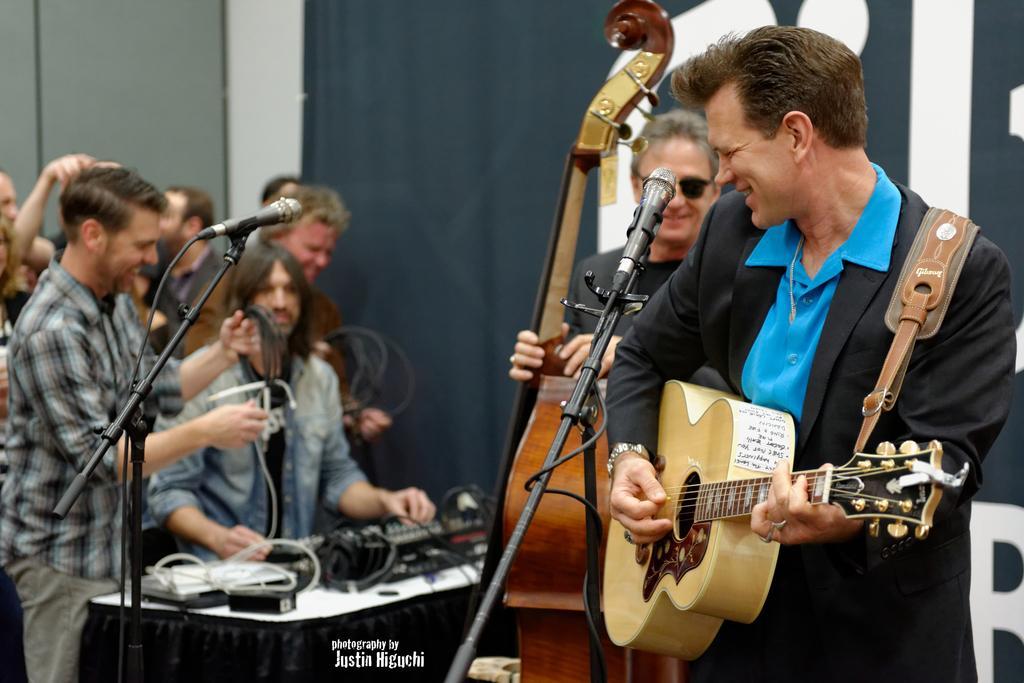How would you summarize this image in a sentence or two? Here we can see two men standing in front of a mike and playing guitar and he is holding a smile on his face. Here we can see all the persons standing and smiling near to these men. On the table we can see sockets. This person is holding wires in his hand. 